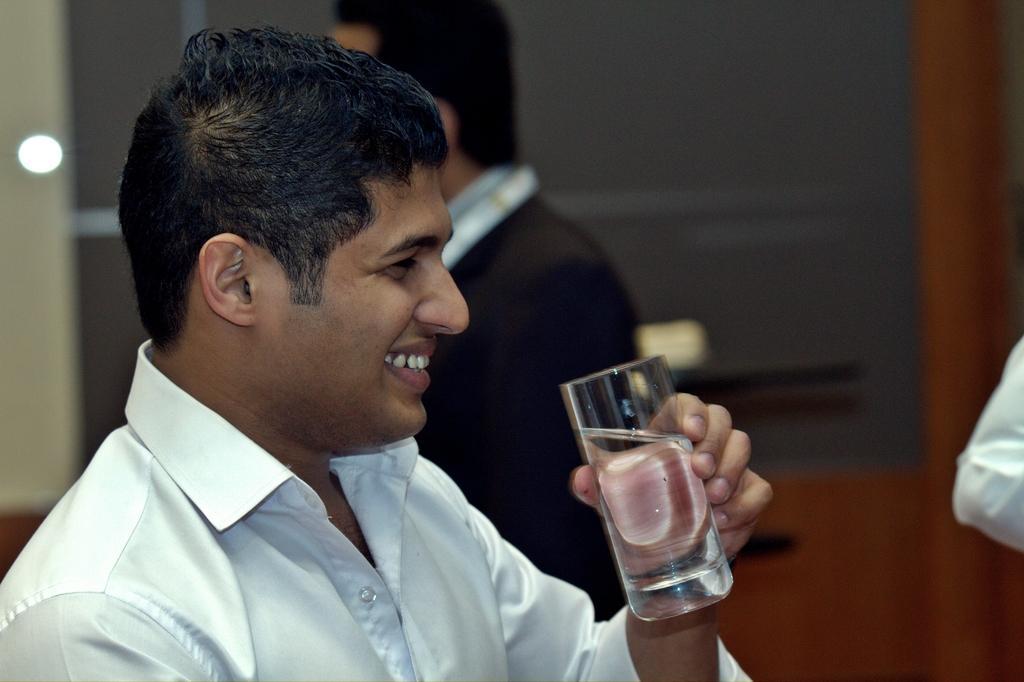How would you summarize this image in a sentence or two? In the picture I can see people among them the man in the front is holding a glass in the hand. The background of the image is blurred. 